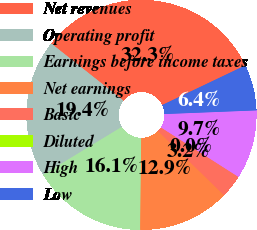Convert chart to OTSL. <chart><loc_0><loc_0><loc_500><loc_500><pie_chart><fcel>Net revenues<fcel>Operating profit<fcel>Earnings before income taxes<fcel>Net earnings<fcel>Basic<fcel>Diluted<fcel>High<fcel>Low<nl><fcel>32.26%<fcel>19.35%<fcel>16.13%<fcel>12.9%<fcel>3.23%<fcel>0.0%<fcel>9.68%<fcel>6.45%<nl></chart> 